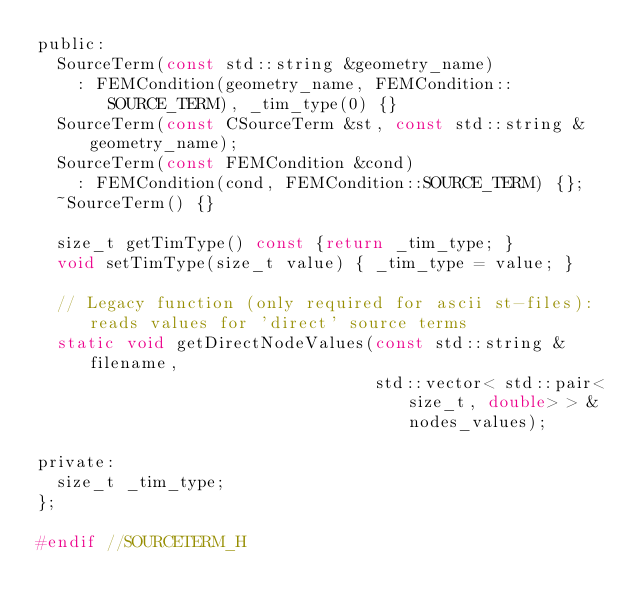Convert code to text. <code><loc_0><loc_0><loc_500><loc_500><_C_>public:
	SourceTerm(const std::string &geometry_name)
		: FEMCondition(geometry_name, FEMCondition::SOURCE_TERM), _tim_type(0) {}
	SourceTerm(const CSourceTerm &st, const std::string &geometry_name);
	SourceTerm(const FEMCondition &cond)
		: FEMCondition(cond, FEMCondition::SOURCE_TERM) {};
	~SourceTerm() {}

	size_t getTimType() const {return _tim_type; }
	void setTimType(size_t value) { _tim_type = value; }

	// Legacy function (only required for ascii st-files): reads values for 'direct' source terms
	static void getDirectNodeValues(const std::string &filename,
	                                std::vector< std::pair<size_t, double> > &nodes_values);

private:
	size_t _tim_type;
};

#endif //SOURCETERM_H
</code> 